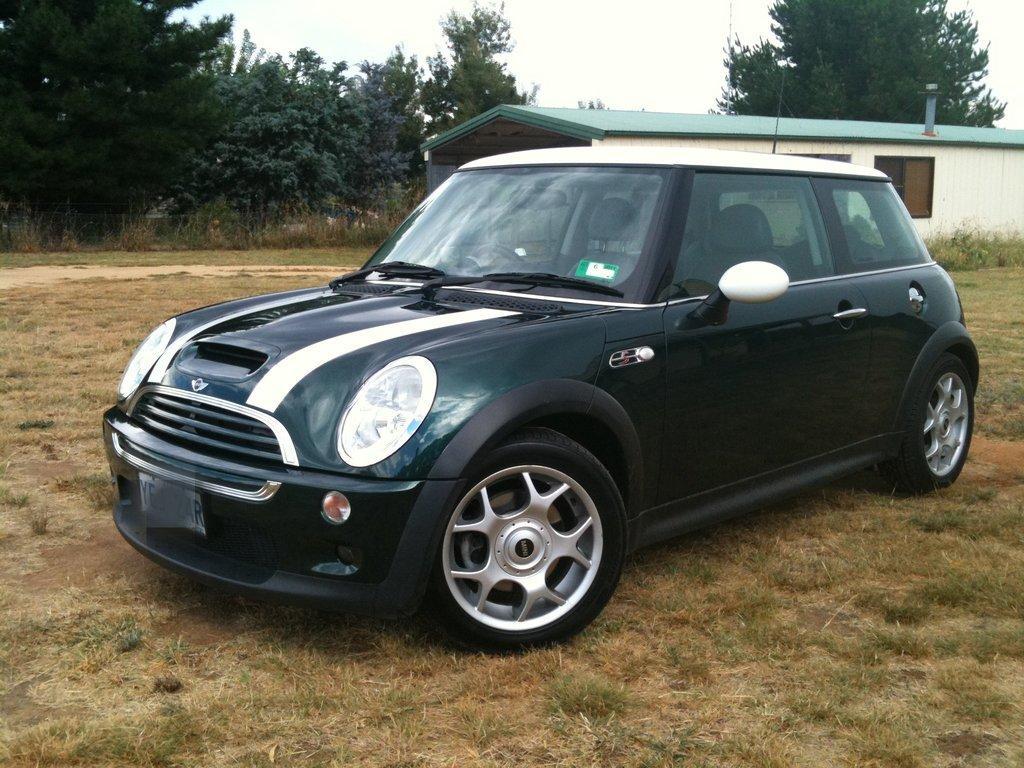Describe this image in one or two sentences. In the image we can see there is a car parked on the ground and the ground is covered with grass. Behind there is a building and there are trees. The sky is clear. 